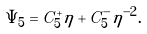<formula> <loc_0><loc_0><loc_500><loc_500>\Psi _ { 5 } = C _ { 5 } ^ { + } \eta + C _ { 5 } ^ { - } \eta ^ { - 2 } .</formula> 